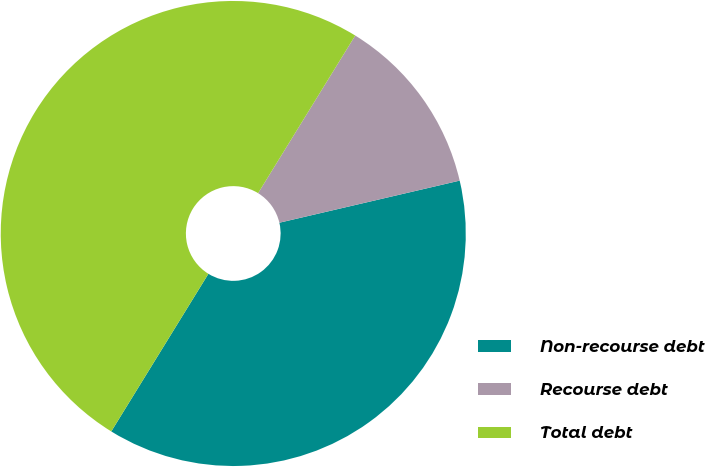Convert chart to OTSL. <chart><loc_0><loc_0><loc_500><loc_500><pie_chart><fcel>Non-recourse debt<fcel>Recourse debt<fcel>Total debt<nl><fcel>37.44%<fcel>12.56%<fcel>50.0%<nl></chart> 